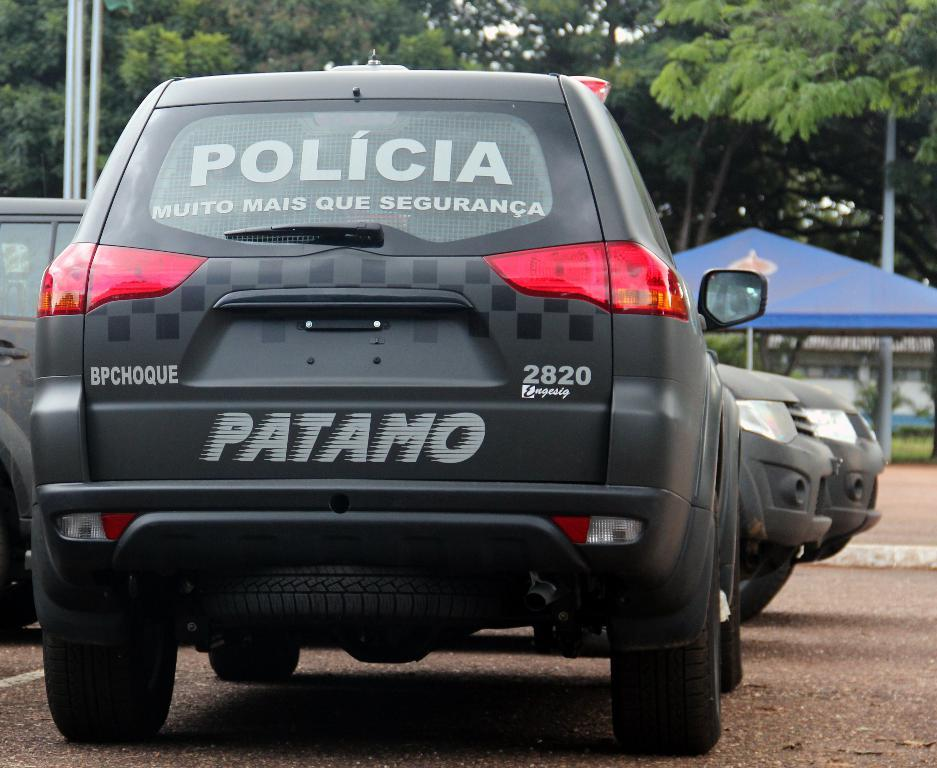How many cars are visible in the image? There are three cars in the image. What can be found on the backside of at least one car? There is text on the backside of at least one car. What type of natural scenery is visible in the background of the image? There are trees in the background of the image. What structure can be seen on the left side of the image? There is a tent on the left side of the image. Can you see any trains or airplanes in the image? No, there are no trains or airplanes present in the image. What type of weather is occurring during the rainstorm in the image? There is no rainstorm present in the image; it is a clear scene with trees in the background. 